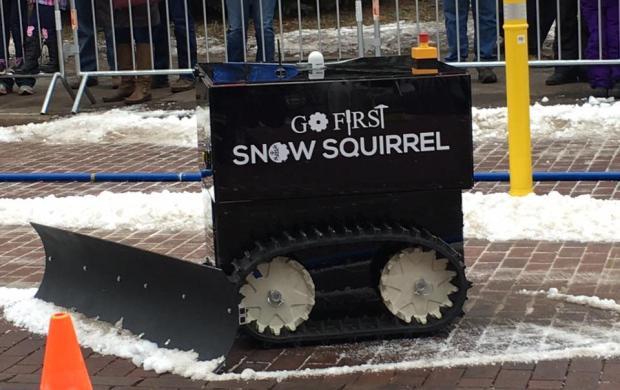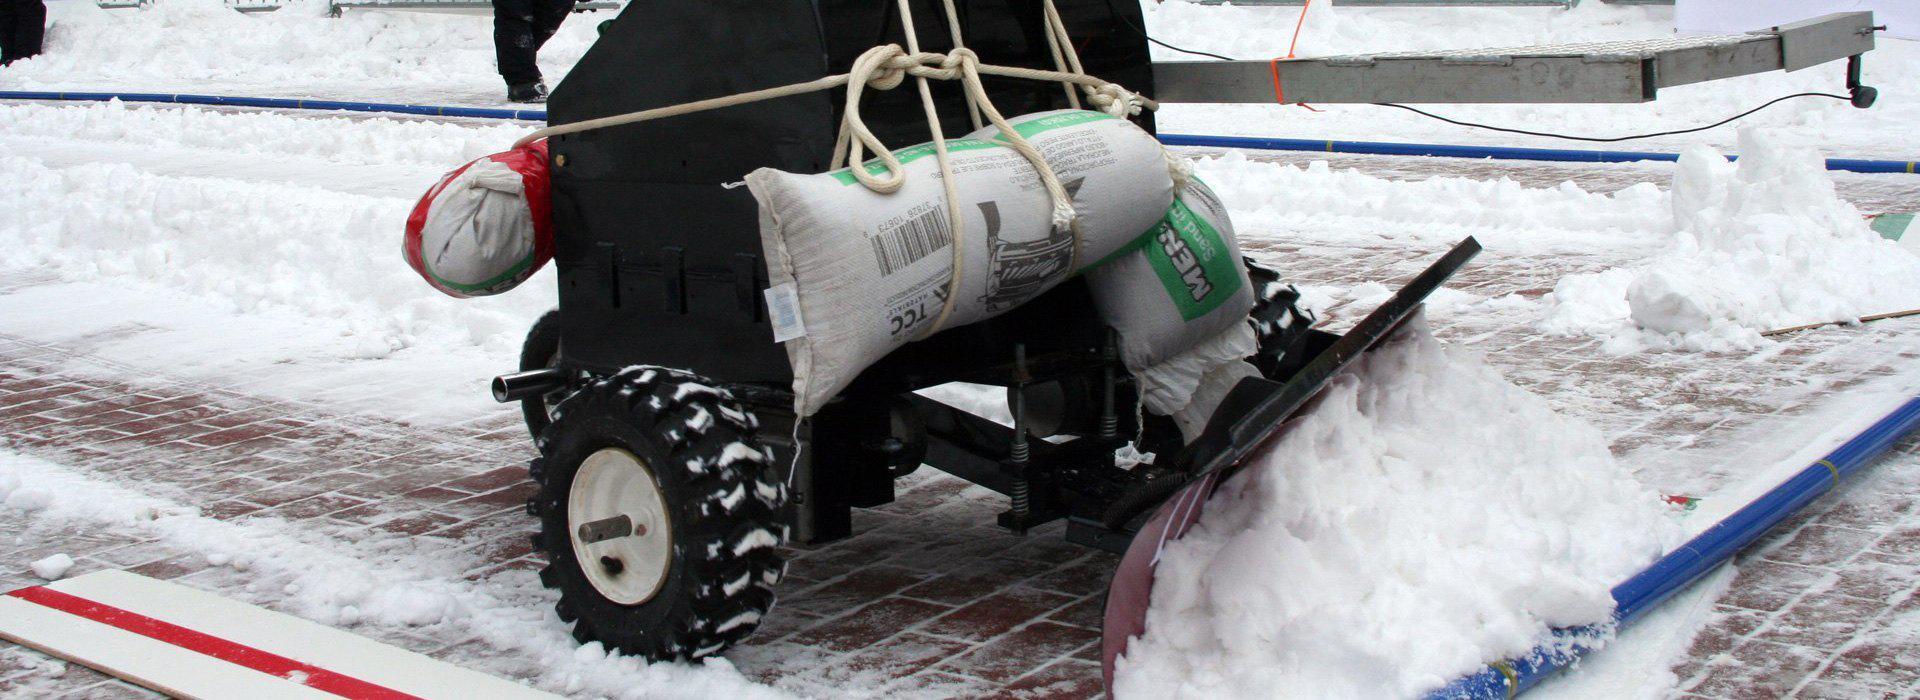The first image is the image on the left, the second image is the image on the right. Assess this claim about the two images: "An image shows a box-shaped machine with a plow, which has no human driver and no truck pulling it.". Correct or not? Answer yes or no. Yes. 